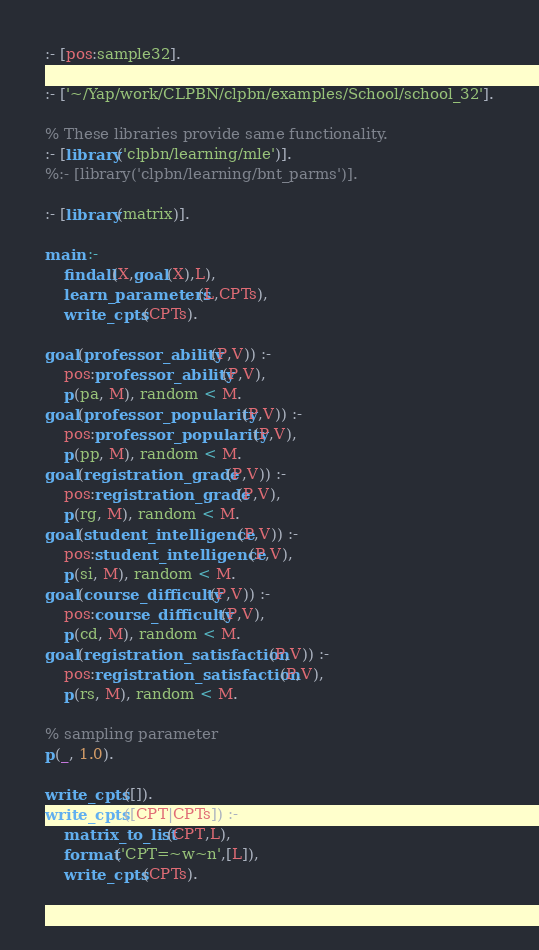Convert code to text. <code><loc_0><loc_0><loc_500><loc_500><_Prolog_>
:- [pos:sample32].

:- ['~/Yap/work/CLPBN/clpbn/examples/School/school_32'].

% These libraries provide same functionality.
:- [library('clpbn/learning/mle')].
%:- [library('clpbn/learning/bnt_parms')].

:- [library(matrix)].

main :-
	findall(X,goal(X),L),
	learn_parameters(L,CPTs),
	write_cpts(CPTs).

goal(professor_ability(P,V)) :-
	pos:professor_ability(P,V),
	p(pa, M), random < M.
goal(professor_popularity(P,V)) :-
	pos:professor_popularity(P,V),
	p(pp, M), random < M.
goal(registration_grade(P,V)) :-
	pos:registration_grade(P,V),
	p(rg, M), random < M.
goal(student_intelligence(P,V)) :-
	pos:student_intelligence(P,V),
	p(si, M), random < M.
goal(course_difficulty(P,V)) :-
	pos:course_difficulty(P,V),
	p(cd, M), random < M.
goal(registration_satisfaction(P,V)) :-
	pos:registration_satisfaction(P,V),
	p(rs, M), random < M.

% sampling parameter
p(_, 1.0).

write_cpts([]).
write_cpts([CPT|CPTs]) :-
	matrix_to_list(CPT,L),
	format('CPT=~w~n',[L]),
	write_cpts(CPTs).
	
</code> 